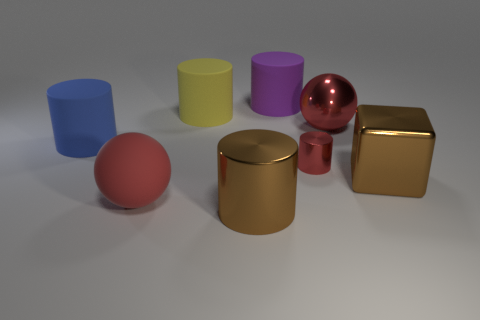Can you explain the lighting and shadows in the image? What does it tell us about the source of light? The lighting in the image seems to be coming from the top left, as indicated by the placement and length of the shadows cast to the opposite side. Each object has a soft-edged shadow suggesting a diffused light source that adds to the serene ambiance of the composition. How might the different textures of the objects interact with the light? Textures can significantly affect how surfaces reflect light. The matte cylinders diffuse light, softening their appearance, while the metallic surfaces of the sphere and cube reflect light sharply, creating bright highlights and defined reflections that accentuate their shapes. 